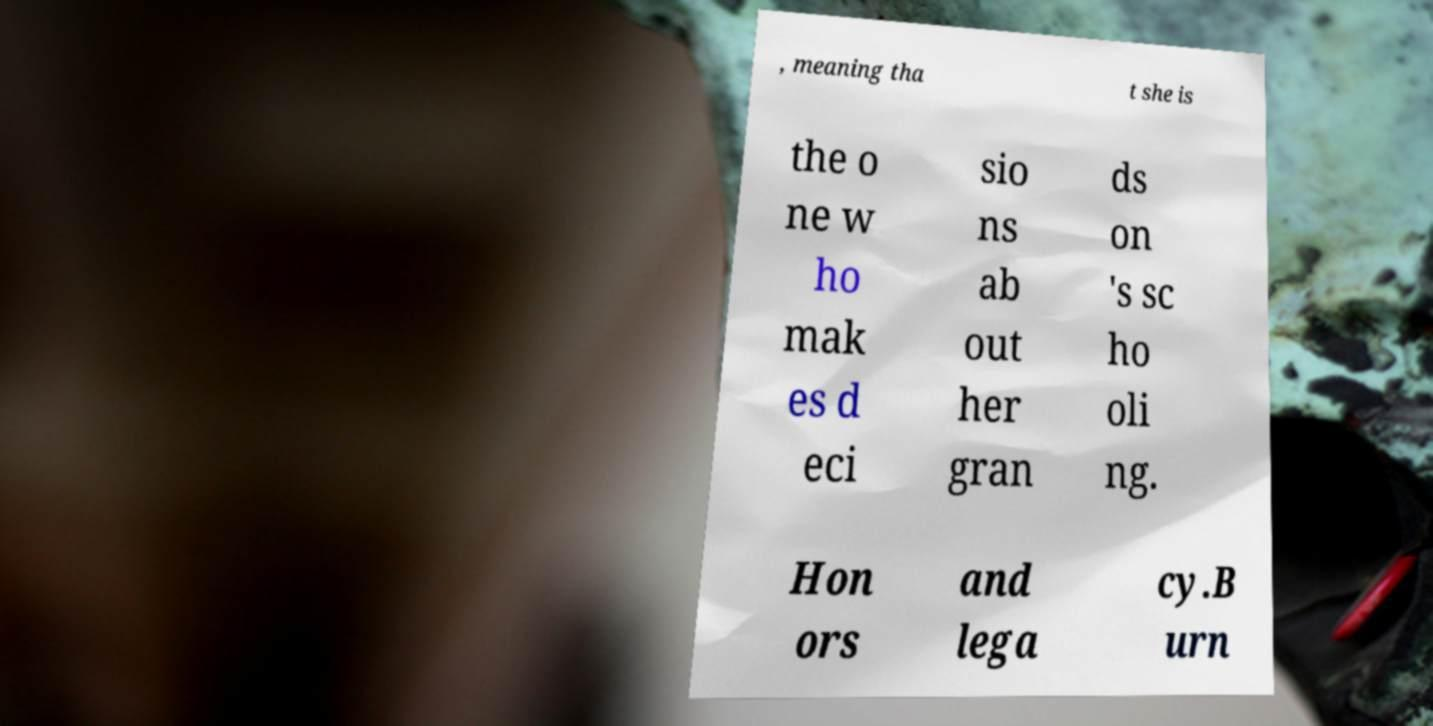What messages or text are displayed in this image? I need them in a readable, typed format. , meaning tha t she is the o ne w ho mak es d eci sio ns ab out her gran ds on 's sc ho oli ng. Hon ors and lega cy.B urn 